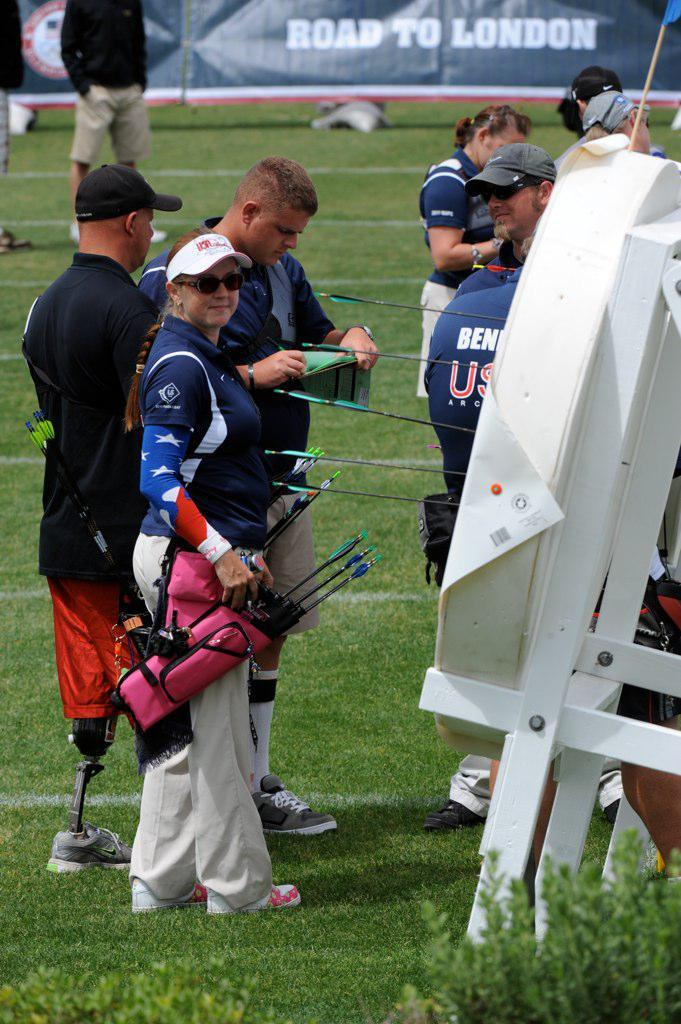<image>
Summarize the visual content of the image. Some athletes on grass in front of a sign that says "Road to London". 